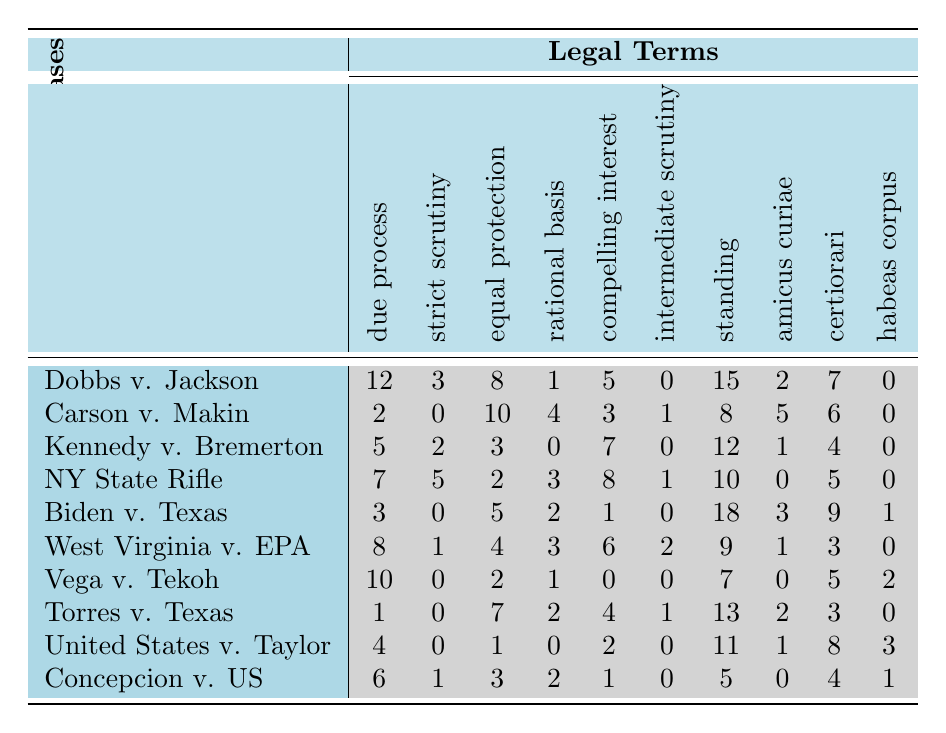What is the highest occurrence of "due process" in the cases listed? Reviewing the data in the "due process" column, the largest number is 12, which appears in "Dobbs v. Jackson Women's Health Organization".
Answer: 12 Which case has the highest number of occurrences for "equal protection"? Looking through the "equal protection" column, "Carson v. Makin" has the highest count with 10 occurrences.
Answer: Carson v. Makin Is there any case that shows zero occurrences of "habeas corpus"? By checking the "habeas corpus" column, I can see that several cases, specifically "Dobbs v. Jackson Women's Health Organization" and "Vega v. Tekoh," show zero occurrences.
Answer: Yes What is the total count of occurrences for "standing" across all cases? Adding the values in the "standing" column gives a total: 15 + 8 + 12 + 10 + 18 + 9 + 7 + 13 + 11 + 5 = 78.
Answer: 78 Which legal term appears most frequently in total across all cases? Calculating the total occurrences for each legal term: for "due process" it’s 12 + 2 + 5 + 7 + 3 + 8 + 10 + 1 + 4 + 6 = 58; "strict scrutiny" is 3 + 0 + 2 + 5 + 0 + 1 + 0 + 0 + 0 + 1 = 12; "equal protection" is 8 + 10 + 3 + 2 + 5 + 4 + 2 + 7 + 1 + 3 = 45; "rational basis" is 1 + 4 + 0 + 3 + 2 + 3 + 1 + 2 + 0 + 2 = 18; "compelling interest" is 5 + 3 + 7 + 8 + 1 + 6 + 0 + 4 + 2 + 1 = 38; "intermediate scrutiny" is 0 + 1 + 0 + 1 + 0 + 2 + 0 + 1 + 0 + 0 = 5; "standing" is 15 + 8 + 12 + 10 + 18 + 9 + 7 + 13 + 11 + 5 = 78; "amicus curiae" is 2 + 5 + 1 + 0 + 3 + 1 + 0 + 2 + 1 + 0 = 15; "certiorari" is 7 + 6 + 4 + 5 + 9 + 3 + 5 + 3 + 8 + 4 = 56; "habeas corpus" is 0 + 0 + 0 + 0 + 1 + 0 + 2 + 0 + 3 + 1 = 7. "Standing" appears most frequently with a total of 78 occurrences.
Answer: standing Which case had the least occurrences of "strict scrutiny"? Checking the "strict scrutiny" column, "Carson v. Makin" shows the lowest number, which is 0 occurrences.
Answer: Carson v. Makin Are there any cases with identical occurrences for the term "compelling interest"? By reviewing the "compelling interest" column, "Biden v. Texas" and "West Virginia v. Environmental Protection Agency" both have 1 occurrence.
Answer: Yes What is the average value of occurrences for "rational basis"? The values for "rational basis" are 1, 4, 0, 3, 2, 3, 1, 2, 0, and 2, summing those gives 18, and then dividing by 10 gives an average of 1.8.
Answer: 1.8 Which case shows the highest count of both "standing" and "habeas corpus"? For "standing," the highest count is 18 in "Biden v. Texas" and for "habeas corpus," the highest is 3 in "United States v. Taylor." However, "Biden v. Texas" has the highest standing, while "habeas corpus" is less relevant since it is lower; thus, "Biden v. Texas" shows the highest count of standing overall.
Answer: Biden v. Texas What is the difference in occurrences for "due process" between "Dobbs v. Jackson Women's Health Organization" and "Torres v. Texas"? The occurrences for "due process" are 12 in "Dobbs v. Jackson Women's Health Organization" and 1 in "Torres v. Texas." The difference is 12 - 1 = 11.
Answer: 11 